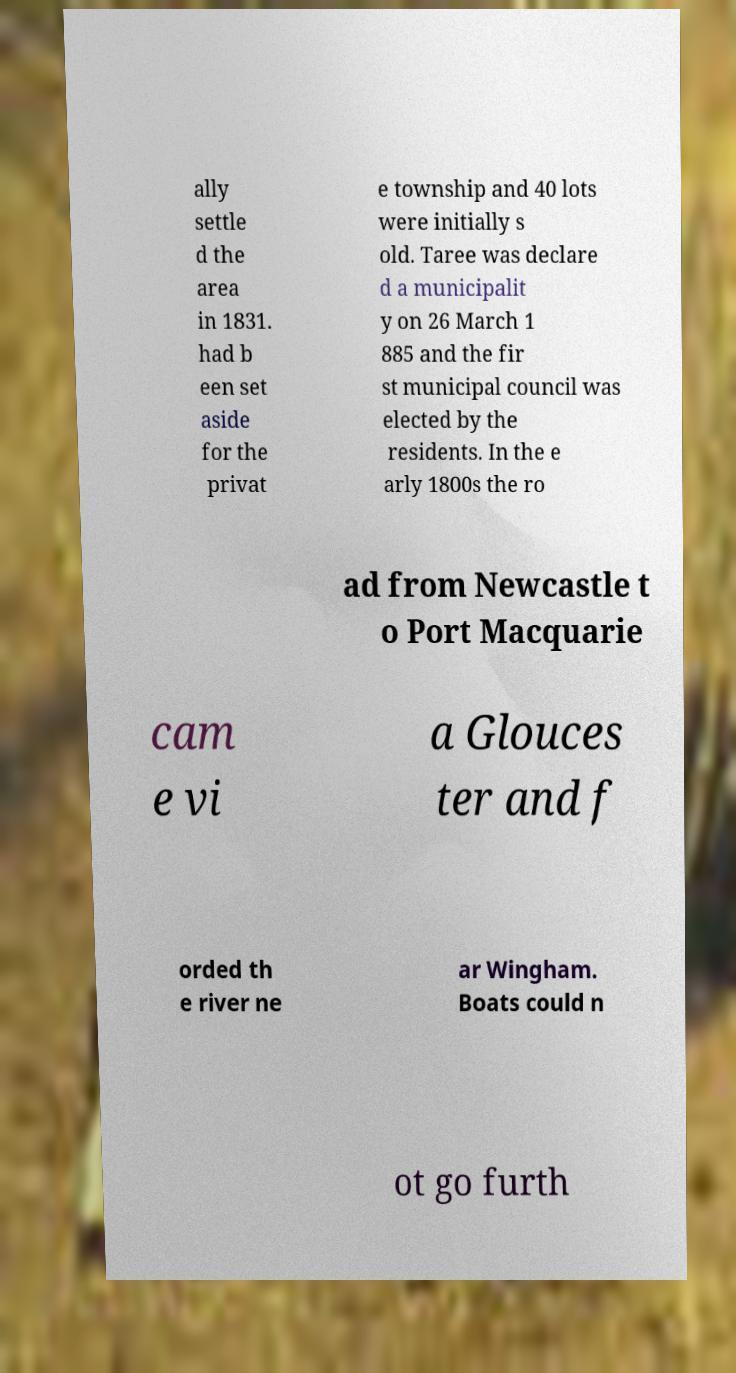Can you read and provide the text displayed in the image?This photo seems to have some interesting text. Can you extract and type it out for me? ally settle d the area in 1831. had b een set aside for the privat e township and 40 lots were initially s old. Taree was declare d a municipalit y on 26 March 1 885 and the fir st municipal council was elected by the residents. In the e arly 1800s the ro ad from Newcastle t o Port Macquarie cam e vi a Glouces ter and f orded th e river ne ar Wingham. Boats could n ot go furth 